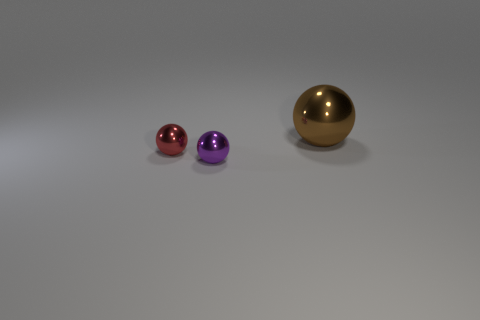Is there any other thing that is the same size as the brown metal ball?
Your answer should be very brief. No. Does the metal thing that is in front of the red object have the same color as the big object?
Keep it short and to the point. No. There is a small thing that is right of the red shiny object; what is its material?
Offer a terse response. Metal. The red metallic object is what size?
Provide a short and direct response. Small. Are the large brown sphere right of the tiny red metallic sphere and the small purple thing made of the same material?
Offer a terse response. Yes. What number of tiny purple spheres are there?
Offer a terse response. 1. What number of objects are either big blue matte things or big brown spheres?
Offer a very short reply. 1. What number of big spheres are on the right side of the tiny thing that is right of the small thing that is to the left of the purple sphere?
Your answer should be very brief. 1. Is there anything else that is the same color as the large ball?
Offer a very short reply. No. Is the color of the sphere that is on the right side of the tiny purple thing the same as the tiny metallic object that is to the left of the tiny purple metal thing?
Give a very brief answer. No. 